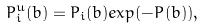<formula> <loc_0><loc_0><loc_500><loc_500>P _ { i } ^ { u } ( b ) = P _ { i } ( b ) e x p ( - P ( b ) ) ,</formula> 